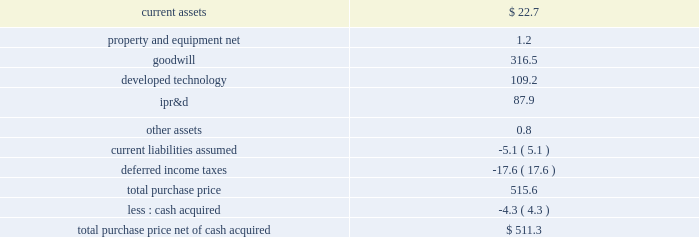Edwards lifesciences corporation notes to consolidated financial statements ( continued ) 7 .
Acquisitions ( continued ) transaction closed on january 23 , 2017 , and the consideration paid included the issuance of approximately 2.8 million shares of the company 2019s common stock ( fair value of $ 266.5 million ) and cash of $ 86.2 million .
The company recognized in 201ccontingent consideration liabilities 201d a $ 162.9 million liability for the estimated fair value of the contingent milestone payments .
The fair value of the contingent milestone payments will be remeasured each quarter , with changes in the fair value recognized within operating expenses on the consolidated statements of operations .
For further information on the fair value of the contingent milestone payments , see note 10 .
In connection with the acquisition , the company placed $ 27.6 million of the purchase price into escrow to satisfy any claims for indemnification made in accordance with the merger agreement .
Any funds remaining 15 months after the acquisition date will be disbursed to valtech 2019s former shareholders .
Acquisition-related costs of $ 0.6 million and $ 4.1 million were recorded in 201cselling , general , and administrative expenses 201d during the years ended december 31 , 2017 and 2016 , respectively .
Prior to the close of the transaction , valtech spun off its early- stage transseptal mitral valve replacement technology program .
Concurrent with the closing , the company entered into an agreement for an exclusive option to acquire that program and its associated intellectual property for approximately $ 200.0 million , subject to certain adjustments , plus an additional $ 50.0 million if a certain european regulatory approval is obtained within 10 years of the acquisition closing date .
The option expires two years after the closing date of the transaction , but can be extended by up to one year depending on the results of certain clinical trials .
Valtech is a developer of a transcatheter mitral and tricuspid valve repair system .
The company plans to add this technology to its portfolio of mitral and tricuspid repair products .
The acquisition was accounted for as a business combination .
Tangible and intangible assets acquired were recorded based on their estimated fair values at the acquisition date .
The excess of the purchase price over the fair value of net assets acquired was recorded to goodwill .
The table summarizes the fair values of the assets acquired and liabilities assumed ( in millions ) : .
Goodwill includes expected synergies and other benefits the company believes will result from the acquisition .
Goodwill was assigned to the company 2019s rest of world segment and is not deductible for tax purposes .
Ipr&d has been capitalized at fair value as an intangible asset with an indefinite life and will be assessed for impairment in subsequent periods .
The fair value of the ipr&d was determined using the income approach .
This approach determines fair value based on cash flow projections which are discounted to present value using a risk-adjusted rate of return .
The discount rates used to determine the fair value of the ipr&d ranged from 18.0% ( 18.0 % ) to 20.0% ( 20.0 % ) .
Completion of successful design developments , bench testing , pre-clinical studies .
What are the acquisition-related costs recorded in 201cselling , general , and administrative expenses 201d as a percentage of current assets? 
Computations: ((0.6 + 4.1) / 22.7)
Answer: 0.20705. 